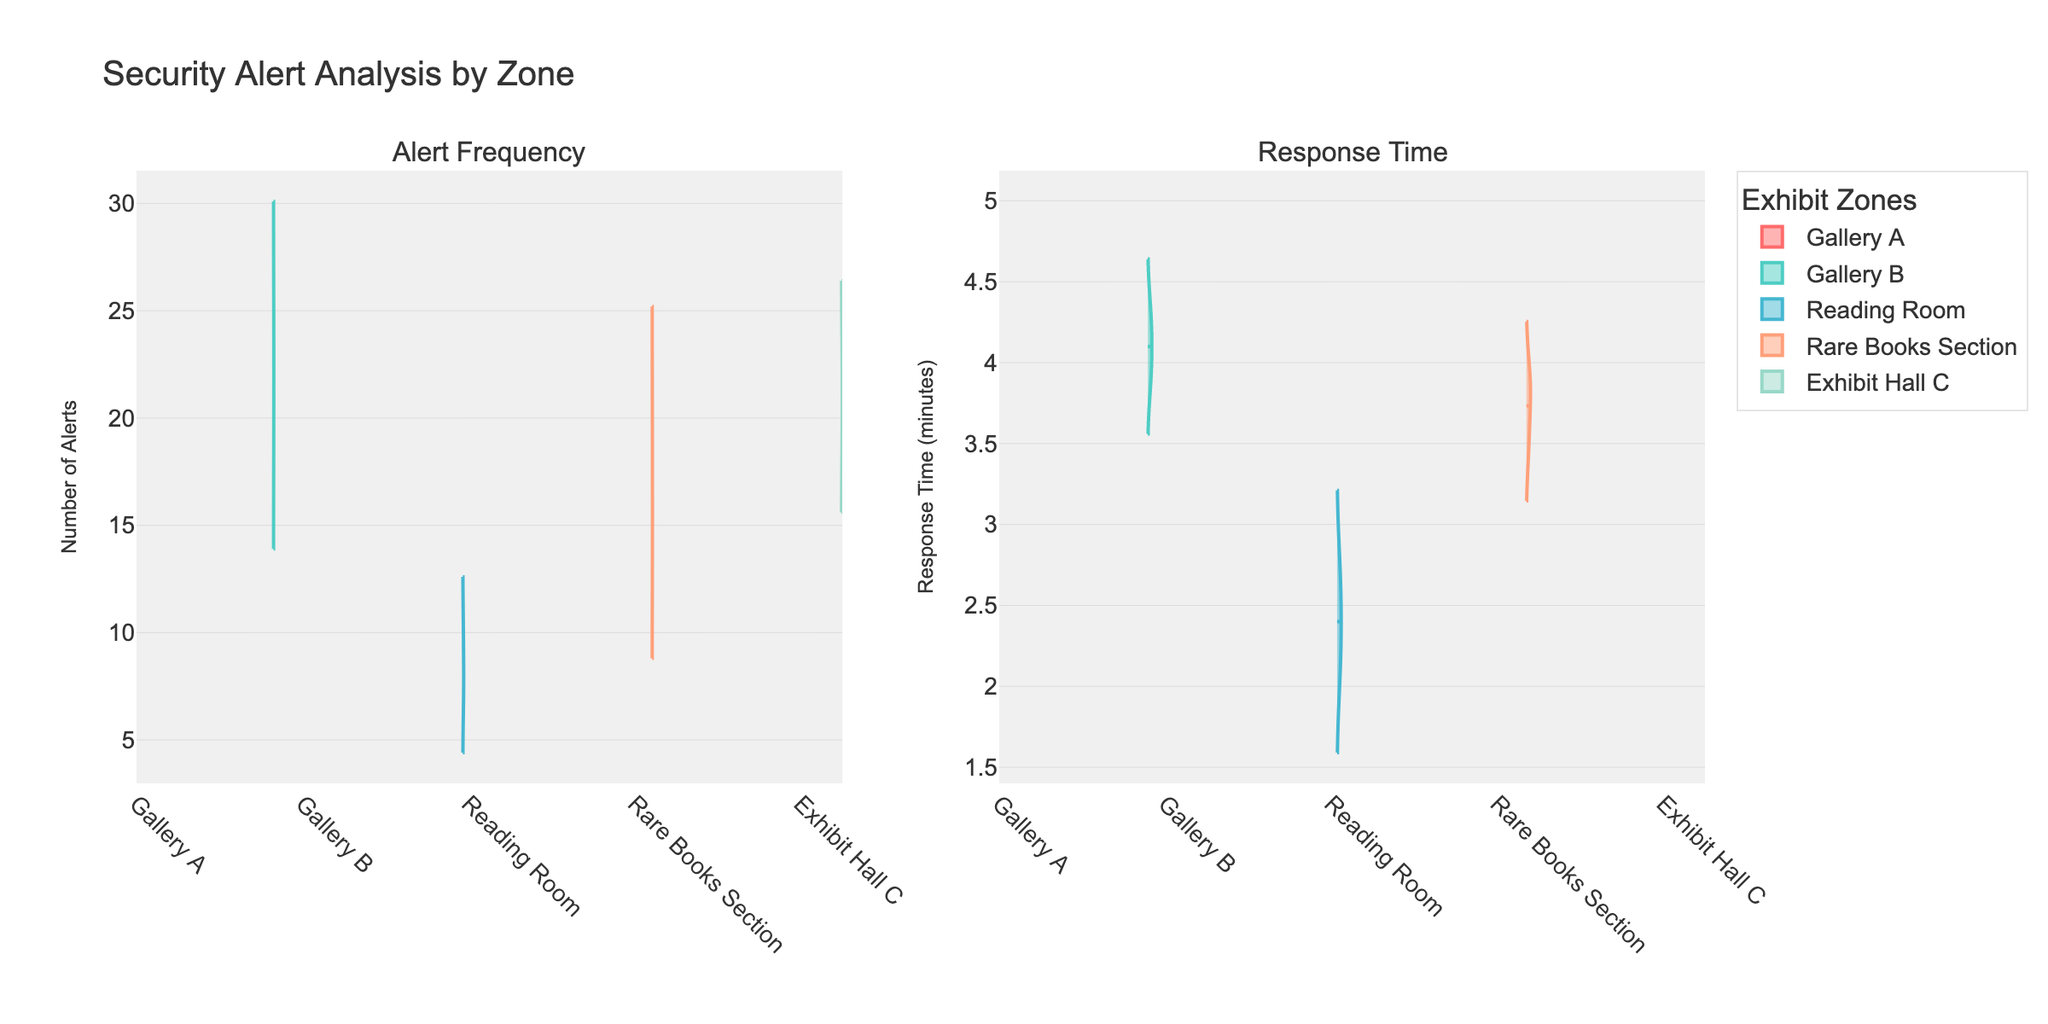What are the two main aspects analyzed in the figure? The figure contains two subplots. The first subplot analyzes "Alert Frequency" by various exhibit zones, while the second subplot analyzes "Response Time" in minutes by the same zones.
Answer: Alert Frequency and Response Time Which zone has the highest average frequency of security alerts? By observing the density plot for the "Frequency" subplot, Gallery B stands out as having the highest concentration of data points towards the higher values. Specifically, the mean line visible in the violin plot reinforces that Gallery B has the highest average frequency.
Answer: Gallery B What is the average response time for Gallery A? In the "Response Time" subplot for Gallery A, the mean line visible helps to indicate the average response time. The average response time for Gallery A is around 3.17 minutes, derived from the plots' mean indicator.
Answer: 3.17 minutes Which zone shows the minimum response time across all zones? Observing the "Response Time" subplot, the lowest end of the response times across all violin plots is for the Reading Room, which shows response times beginning around 2.1 minutes.
Answer: Reading Room How do the frequency distributions of Gallery B and Exhibit Hall C compare? Comparing the "Frequency" subplot, Gallery B's distribution is centered around higher values, while Exhibit Hall C has a slightly lower and narrower distribution. This indicates that Gallery B generally has a higher frequency of alerts compared to Exhibit Hall C.
Answer: Gallery B has a higher frequency What is the trend in response time visible in Exhibit Hall C compared to Gallery A? In the "Response Time" subplot, Exhibit Hall C shows response times generally in the range of 3.7 - 4.4 minutes, with a mean around 4.03 minutes, whereas Gallery A shows a range of 2.8 - 3.5 minutes with a mean around 3.17 minutes. Exhibit Hall C tends towards higher response times compared to Gallery A.
Answer: Higher in Exhibit Hall C In terms of response time, which two zones have somewhat similar distributions? In the "Response Time" subplot, Gallery B and Exhibit Hall C show somewhat similar distributions in terms of range and concentration around higher response time values close to 4 minutes. Their distributions almost overlap at points.
Answer: Gallery B and Exhibit Hall C What observation can be made about the alert frequency in the Reading Room? The density plot for "Frequency" in the Reading Room indicates fewer data points and a lower spread, with frequency values mainly between 7 and 10. This suggests a lower frequency of alerts in this zone.
Answer: Fewer alerts in Reading Room Which zone has the highest variability in response times? Observing the "Response Time" subplot, Exhibit Hall C shows a wider spread ranging from approximately 3.7 to 4.4 minutes, indicating higher variability in response times compared to other zones.
Answer: Exhibit Hall C Are the response times for the Rare Books Section higher or lower than those for Gallery A? In the "Response Time" subplot, response times for the Rare Books Section range from 3.5 to 3.9 minutes. For Gallery A, the range is lower at 2.8 to 3.5 minutes. This indicates higher response times for the Rare Books Section compared to Gallery A.
Answer: Higher in Rare Books Section 